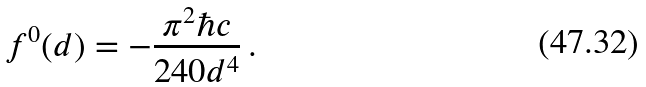<formula> <loc_0><loc_0><loc_500><loc_500>f ^ { 0 } ( d ) = - \frac { \pi ^ { 2 } \hbar { c } } { 2 4 0 d ^ { 4 } } \, .</formula> 